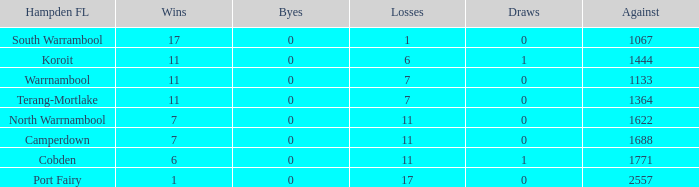Help me parse the entirety of this table. {'header': ['Hampden FL', 'Wins', 'Byes', 'Losses', 'Draws', 'Against'], 'rows': [['South Warrambool', '17', '0', '1', '0', '1067'], ['Koroit', '11', '0', '6', '1', '1444'], ['Warrnambool', '11', '0', '7', '0', '1133'], ['Terang-Mortlake', '11', '0', '7', '0', '1364'], ['North Warrnambool', '7', '0', '11', '0', '1622'], ['Camperdown', '7', '0', '11', '0', '1688'], ['Cobden', '6', '0', '11', '1', '1771'], ['Port Fairy', '1', '0', '17', '0', '2557']]} What were the losses when the byes were lesser than 0? None. 